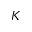<formula> <loc_0><loc_0><loc_500><loc_500>K</formula> 